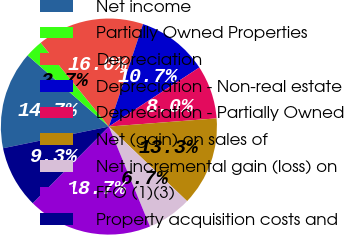Convert chart. <chart><loc_0><loc_0><loc_500><loc_500><pie_chart><fcel>Net income<fcel>Partially Owned Properties<fcel>Depreciation<fcel>Depreciation - Non-real estate<fcel>Depreciation - Partially Owned<fcel>Net (gain) on sales of<fcel>Net incremental gain (loss) on<fcel>FFO (1)(3)<fcel>Property acquisition costs and<nl><fcel>14.66%<fcel>2.68%<fcel>15.99%<fcel>10.67%<fcel>8.0%<fcel>13.33%<fcel>6.67%<fcel>18.65%<fcel>9.34%<nl></chart> 